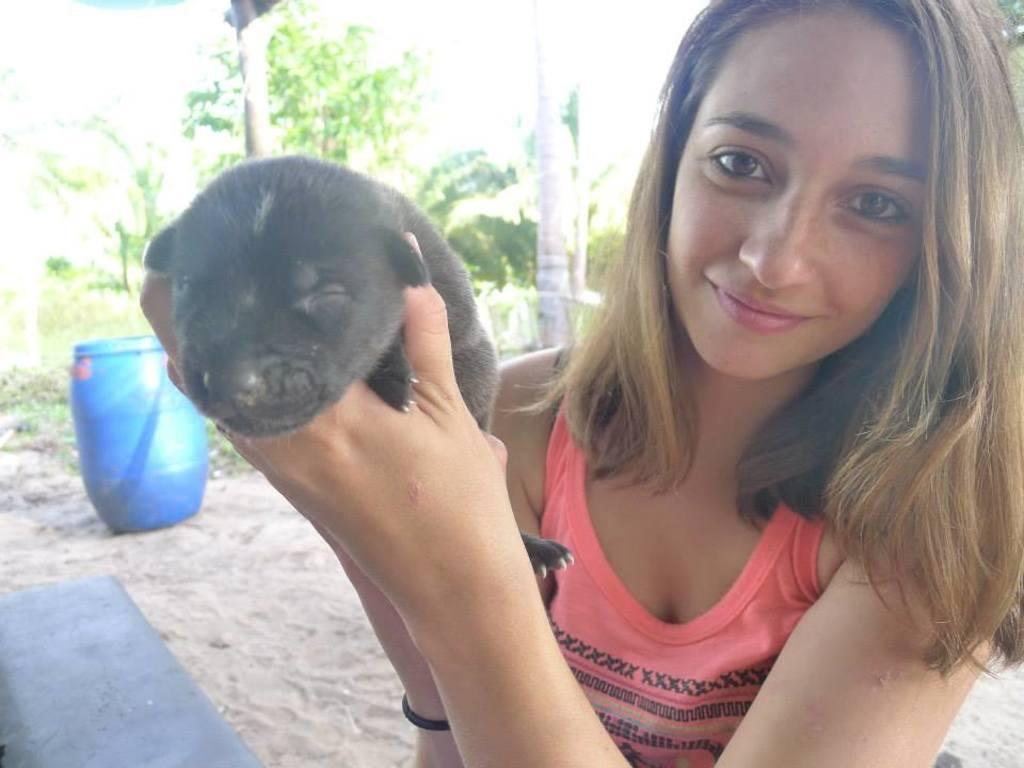Who is the main subject in the image? There is a woman in the center of the image. What is the woman doing in the image? The woman is smiling and holding a puppy. What can be seen in the background of the image? There are trees in the background of the image. What other object is present at the bottom of the image? There is a drum at the bottom of the image. What type of curtain can be seen in the image? There is no curtain present in the image. What effect does the woman's smile have on the puppy in the image? The image does not show the puppy's reaction to the woman's smile, so we cannot determine the effect it has on the puppy. 